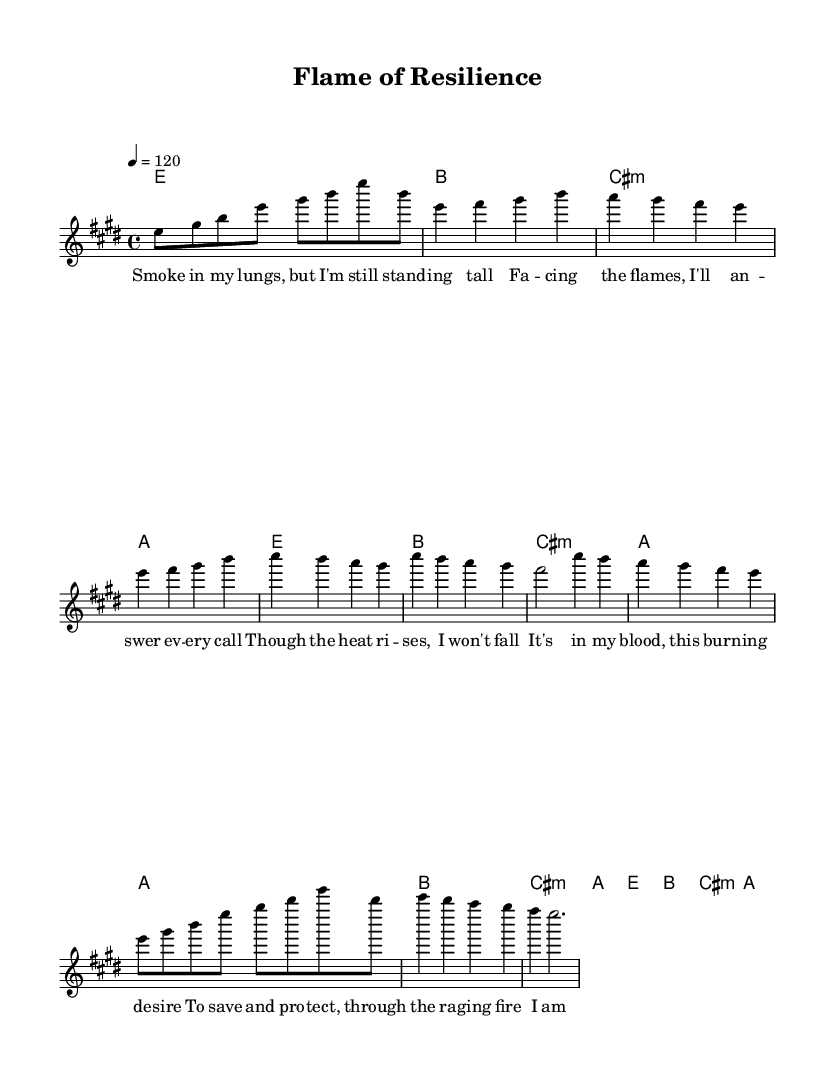What is the key signature of this music? The key signature indicates E major, which has four sharps: F#, C#, G#, and D#. This can be determined by looking at the key signature notation at the beginning of the score.
Answer: E major What is the time signature of this music? The time signature is located at the beginning of the score and indicates how many beats are in each measure. In this case, it shows 4/4, meaning there are four beats per measure.
Answer: 4/4 What is the tempo marking for this piece? The tempo marking is found within the score and specifies the speed of the music. Here, the marking indicates 120 beats per minute, which is represented by the note value (4 = 120).
Answer: 120 How many measures are in the chorus? The chorus section consists of two measures as indicated by the notation and the grouping of the melody and lyrics within that section. Each line in the chorus corresponds to one measure.
Answer: 2 Which chords are used in the pre-chorus? The pre-chorus section includes three chords: A, B, and C# minor. By examining the chord symbols under the melody during the pre-chorus, we can identify these chords.
Answer: A, B, C# minor What is the main theme of the lyrics in the verse? The lyrics in the verse communicate themes of resilience and determination, particularly in the face of challenges. When analyzing the text, it depicts the struggle against smoke and fire, representing overcoming adversity.
Answer: Resilience Who is the intended emotional audience for this song? The song's lyrics describe feelings of strength and hope, suggesting an audience that may be experiencing hardship or adversity, especially individuals who seek motivation or inspiration in difficult times. This is inferred from the overall message and tone of the lyrics.
Answer: Overcoming adversity 